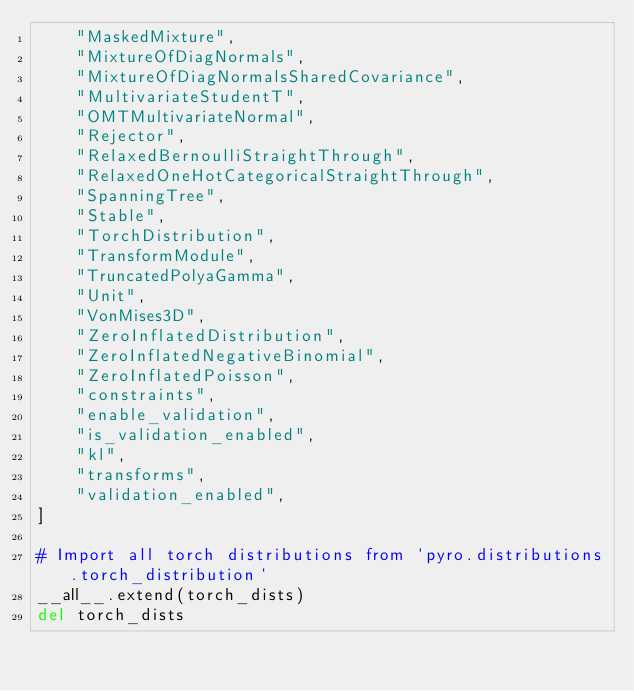Convert code to text. <code><loc_0><loc_0><loc_500><loc_500><_Python_>    "MaskedMixture",
    "MixtureOfDiagNormals",
    "MixtureOfDiagNormalsSharedCovariance",
    "MultivariateStudentT",
    "OMTMultivariateNormal",
    "Rejector",
    "RelaxedBernoulliStraightThrough",
    "RelaxedOneHotCategoricalStraightThrough",
    "SpanningTree",
    "Stable",
    "TorchDistribution",
    "TransformModule",
    "TruncatedPolyaGamma",
    "Unit",
    "VonMises3D",
    "ZeroInflatedDistribution",
    "ZeroInflatedNegativeBinomial",
    "ZeroInflatedPoisson",
    "constraints",
    "enable_validation",
    "is_validation_enabled",
    "kl",
    "transforms",
    "validation_enabled",
]

# Import all torch distributions from `pyro.distributions.torch_distribution`
__all__.extend(torch_dists)
del torch_dists
</code> 